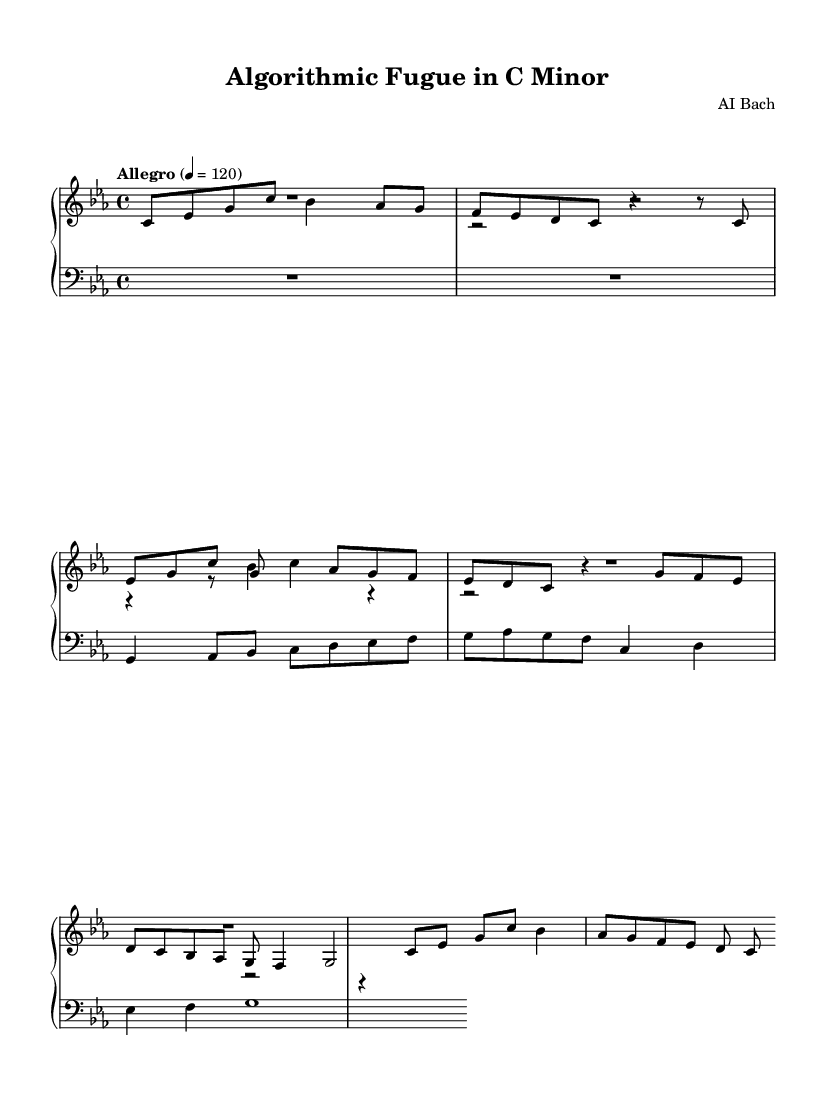What is the key signature of this music? The key signature is indicated by the flat symbols in the key signature area at the beginning of the staff. Here, there are six flats, which identifies the piece as being in C minor.
Answer: C minor What is the time signature of this piece? The time signature is located at the beginning of the score, shown as a fraction indicating how many beats are in each measure. Here, it is written as 4/4, meaning there are four beats per measure, and a quarter note gets one beat.
Answer: 4/4 What is the tempo marking for this piece? The tempo marking is noted above the staff and indicates the speed of the piece. In this case, it states "Allegro" with a metronome marking of 120, suggesting a fast and lively tempo.
Answer: Allegro How many voices are present in this score? By examining the layout of the score, we see three distinct voices (one for the upper staff and two for the lower staff), meaning there are a total of three voices.
Answer: 3 What is the structural form of this composition? This composition follows a fugue structure, indicated by the presence of a subject and countersubject, which are characteristic elements of a fugue where motifs are developed through various voices.
Answer: Fugue What is the first note of the subject? The subject starts on a C note, which can be identified by looking at the first note in the subject line of the sheet music.
Answer: C What is the relationship between the subject and the countersubject in terms of pitch? The subject begins with a C and moves upwards, while the countersubject begins with a G, indicating that the countersubject is pitched a perfect fifth above the subject. This relationship is common in contrapuntal music for creating harmonies and thematic development.
Answer: Perfect fifth 